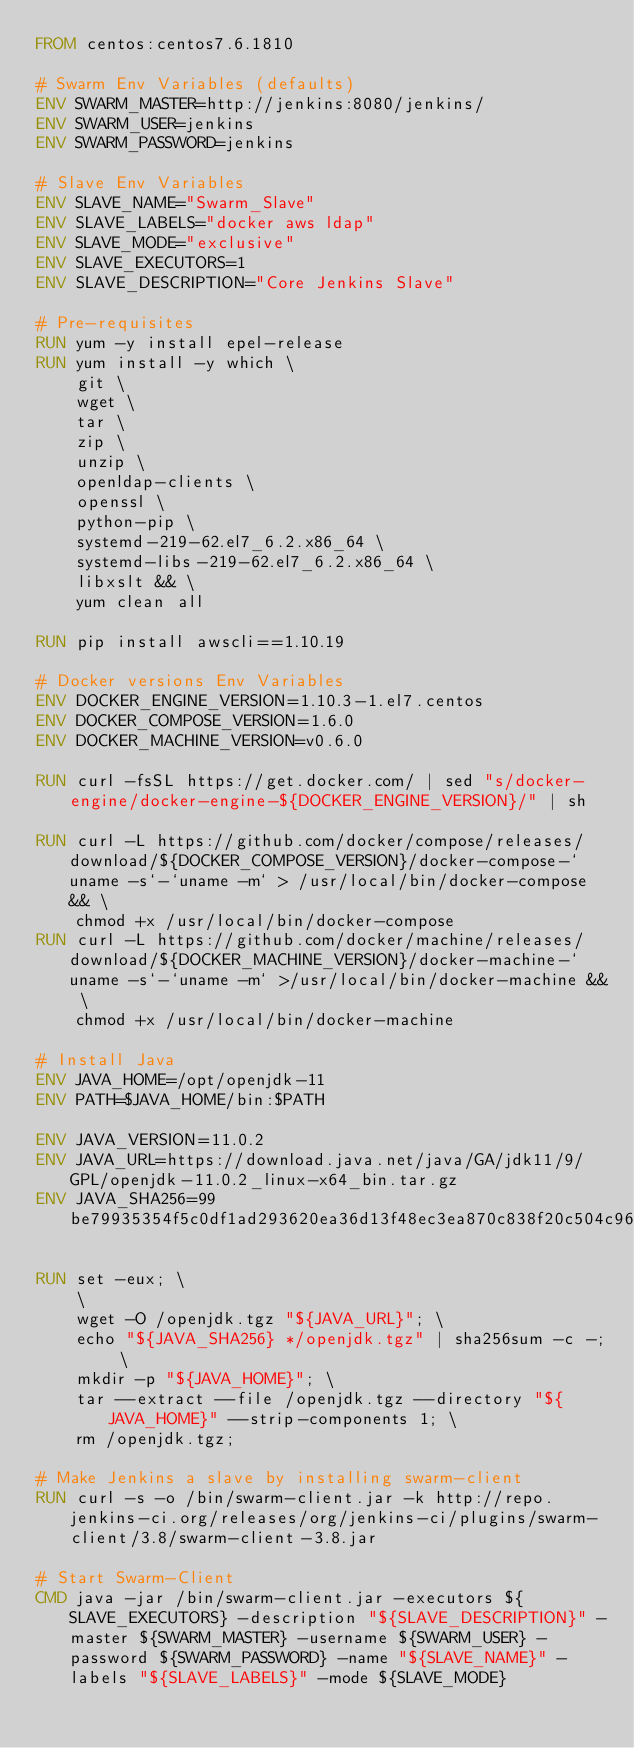Convert code to text. <code><loc_0><loc_0><loc_500><loc_500><_Dockerfile_>FROM centos:centos7.6.1810

# Swarm Env Variables (defaults)
ENV SWARM_MASTER=http://jenkins:8080/jenkins/
ENV SWARM_USER=jenkins
ENV SWARM_PASSWORD=jenkins

# Slave Env Variables
ENV SLAVE_NAME="Swarm_Slave"
ENV SLAVE_LABELS="docker aws ldap"
ENV SLAVE_MODE="exclusive"
ENV SLAVE_EXECUTORS=1
ENV SLAVE_DESCRIPTION="Core Jenkins Slave"

# Pre-requisites
RUN yum -y install epel-release
RUN yum install -y which \
    git \
    wget \
    tar \
    zip \
    unzip \
    openldap-clients \
    openssl \
    python-pip \
    systemd-219-62.el7_6.2.x86_64 \
    systemd-libs-219-62.el7_6.2.x86_64 \
    libxslt && \
    yum clean all 

RUN pip install awscli==1.10.19

# Docker versions Env Variables
ENV DOCKER_ENGINE_VERSION=1.10.3-1.el7.centos
ENV DOCKER_COMPOSE_VERSION=1.6.0
ENV DOCKER_MACHINE_VERSION=v0.6.0

RUN curl -fsSL https://get.docker.com/ | sed "s/docker-engine/docker-engine-${DOCKER_ENGINE_VERSION}/" | sh

RUN curl -L https://github.com/docker/compose/releases/download/${DOCKER_COMPOSE_VERSION}/docker-compose-`uname -s`-`uname -m` > /usr/local/bin/docker-compose && \
    chmod +x /usr/local/bin/docker-compose
RUN curl -L https://github.com/docker/machine/releases/download/${DOCKER_MACHINE_VERSION}/docker-machine-`uname -s`-`uname -m` >/usr/local/bin/docker-machine && \
    chmod +x /usr/local/bin/docker-machine

# Install Java
ENV JAVA_HOME=/opt/openjdk-11
ENV PATH=$JAVA_HOME/bin:$PATH

ENV JAVA_VERSION=11.0.2
ENV JAVA_URL=https://download.java.net/java/GA/jdk11/9/GPL/openjdk-11.0.2_linux-x64_bin.tar.gz
ENV JAVA_SHA256=99be79935354f5c0df1ad293620ea36d13f48ec3ea870c838f20c504c9668b57

RUN set -eux; \
    \
    wget -O /openjdk.tgz "${JAVA_URL}"; \
    echo "${JAVA_SHA256} */openjdk.tgz" | sha256sum -c -; \
    mkdir -p "${JAVA_HOME}"; \
    tar --extract --file /openjdk.tgz --directory "${JAVA_HOME}" --strip-components 1; \
    rm /openjdk.tgz;
           
# Make Jenkins a slave by installing swarm-client
RUN curl -s -o /bin/swarm-client.jar -k http://repo.jenkins-ci.org/releases/org/jenkins-ci/plugins/swarm-client/3.8/swarm-client-3.8.jar

# Start Swarm-Client
CMD java -jar /bin/swarm-client.jar -executors ${SLAVE_EXECUTORS} -description "${SLAVE_DESCRIPTION}" -master ${SWARM_MASTER} -username ${SWARM_USER} -password ${SWARM_PASSWORD} -name "${SLAVE_NAME}" -labels "${SLAVE_LABELS}" -mode ${SLAVE_MODE}
</code> 